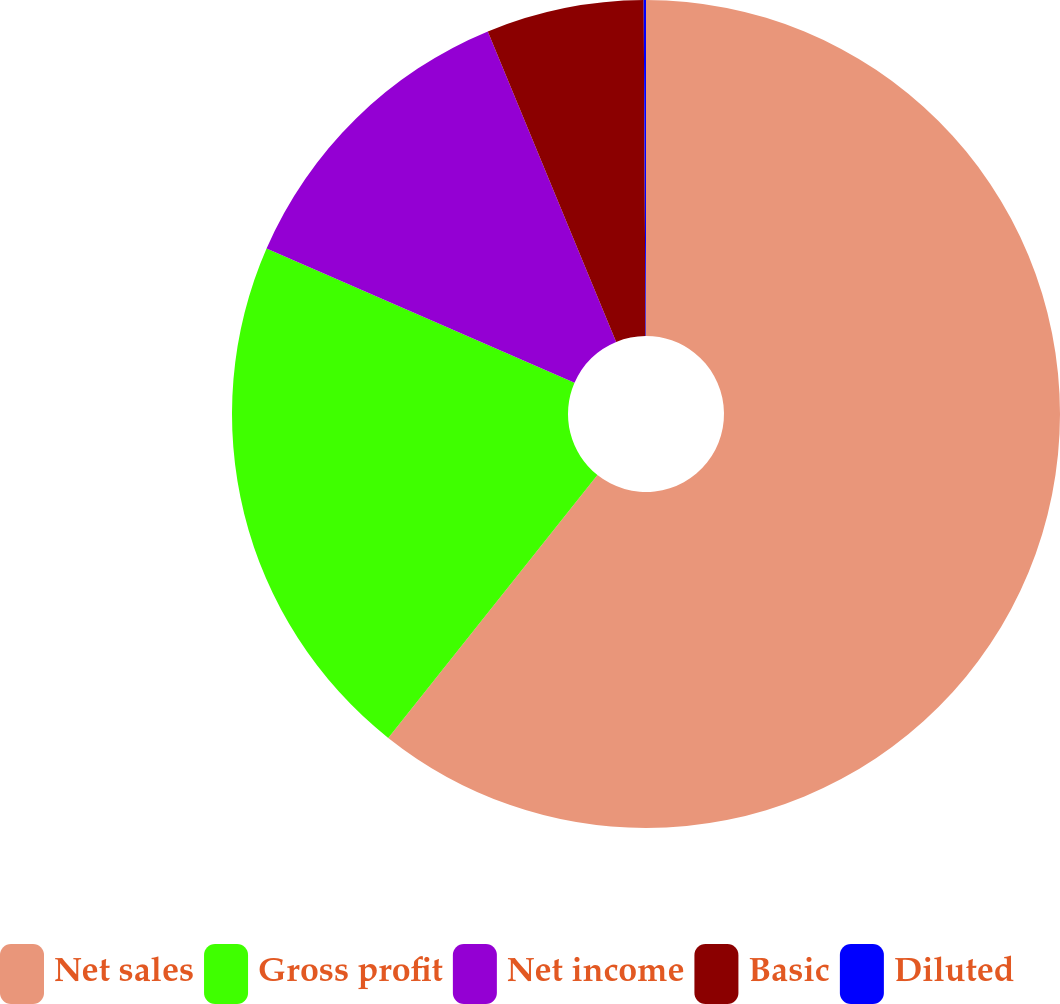Convert chart. <chart><loc_0><loc_0><loc_500><loc_500><pie_chart><fcel>Net sales<fcel>Gross profit<fcel>Net income<fcel>Basic<fcel>Diluted<nl><fcel>60.69%<fcel>20.85%<fcel>12.21%<fcel>6.15%<fcel>0.09%<nl></chart> 